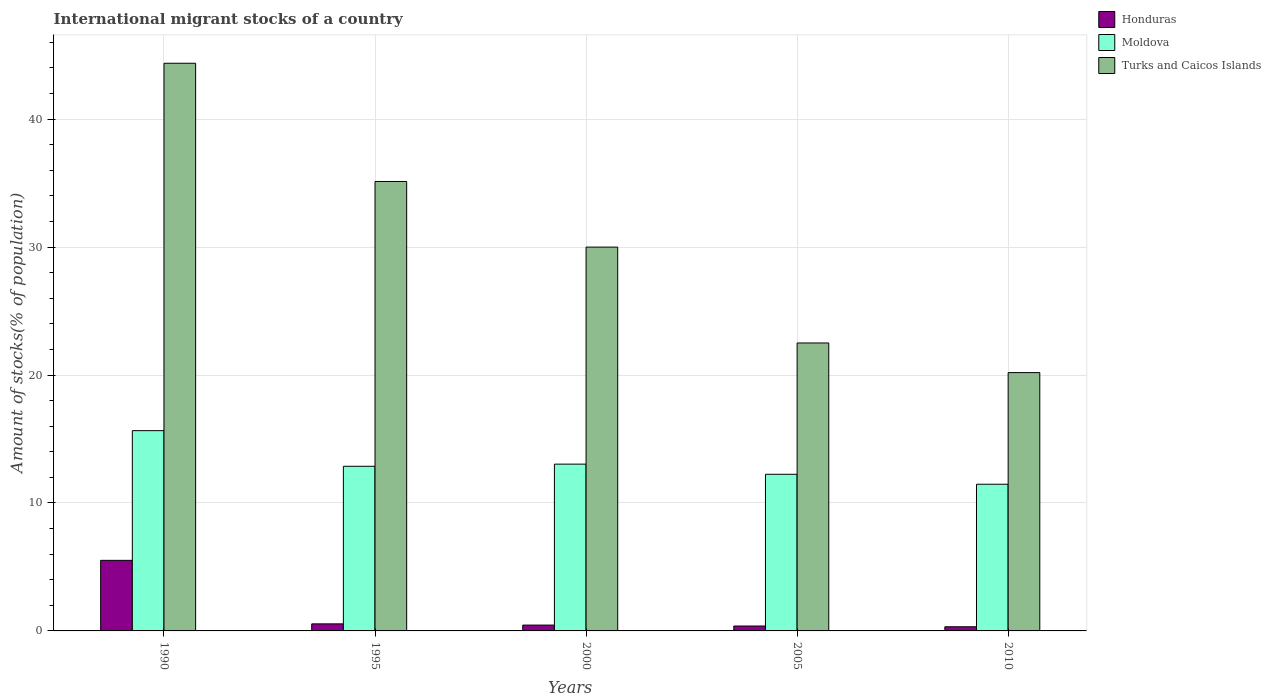How many groups of bars are there?
Your answer should be very brief. 5. Are the number of bars per tick equal to the number of legend labels?
Your answer should be very brief. Yes. Are the number of bars on each tick of the X-axis equal?
Your answer should be very brief. Yes. How many bars are there on the 3rd tick from the right?
Provide a succinct answer. 3. What is the label of the 2nd group of bars from the left?
Your answer should be very brief. 1995. In how many cases, is the number of bars for a given year not equal to the number of legend labels?
Offer a terse response. 0. What is the amount of stocks in in Honduras in 1990?
Give a very brief answer. 5.52. Across all years, what is the maximum amount of stocks in in Turks and Caicos Islands?
Provide a succinct answer. 44.36. Across all years, what is the minimum amount of stocks in in Turks and Caicos Islands?
Provide a succinct answer. 20.19. In which year was the amount of stocks in in Turks and Caicos Islands minimum?
Offer a terse response. 2010. What is the total amount of stocks in in Turks and Caicos Islands in the graph?
Make the answer very short. 152.18. What is the difference between the amount of stocks in in Turks and Caicos Islands in 1995 and that in 2005?
Provide a short and direct response. 12.62. What is the difference between the amount of stocks in in Moldova in 2005 and the amount of stocks in in Honduras in 1995?
Provide a short and direct response. 11.69. What is the average amount of stocks in in Honduras per year?
Make the answer very short. 1.45. In the year 2005, what is the difference between the amount of stocks in in Moldova and amount of stocks in in Turks and Caicos Islands?
Provide a short and direct response. -10.26. In how many years, is the amount of stocks in in Turks and Caicos Islands greater than 12 %?
Offer a very short reply. 5. What is the ratio of the amount of stocks in in Turks and Caicos Islands in 2000 to that in 2005?
Keep it short and to the point. 1.33. Is the amount of stocks in in Turks and Caicos Islands in 1990 less than that in 1995?
Offer a terse response. No. What is the difference between the highest and the second highest amount of stocks in in Honduras?
Keep it short and to the point. 4.96. What is the difference between the highest and the lowest amount of stocks in in Turks and Caicos Islands?
Make the answer very short. 24.18. In how many years, is the amount of stocks in in Honduras greater than the average amount of stocks in in Honduras taken over all years?
Offer a terse response. 1. Is the sum of the amount of stocks in in Moldova in 1990 and 2005 greater than the maximum amount of stocks in in Honduras across all years?
Your answer should be very brief. Yes. What does the 1st bar from the left in 2010 represents?
Ensure brevity in your answer.  Honduras. What does the 3rd bar from the right in 2010 represents?
Keep it short and to the point. Honduras. Is it the case that in every year, the sum of the amount of stocks in in Honduras and amount of stocks in in Moldova is greater than the amount of stocks in in Turks and Caicos Islands?
Offer a very short reply. No. What is the difference between two consecutive major ticks on the Y-axis?
Provide a succinct answer. 10. Does the graph contain any zero values?
Provide a short and direct response. No. How many legend labels are there?
Give a very brief answer. 3. What is the title of the graph?
Offer a terse response. International migrant stocks of a country. What is the label or title of the Y-axis?
Ensure brevity in your answer.  Amount of stocks(% of population). What is the Amount of stocks(% of population) in Honduras in 1990?
Offer a terse response. 5.52. What is the Amount of stocks(% of population) of Moldova in 1990?
Ensure brevity in your answer.  15.65. What is the Amount of stocks(% of population) of Turks and Caicos Islands in 1990?
Make the answer very short. 44.36. What is the Amount of stocks(% of population) of Honduras in 1995?
Provide a succinct answer. 0.55. What is the Amount of stocks(% of population) of Moldova in 1995?
Your answer should be very brief. 12.87. What is the Amount of stocks(% of population) of Turks and Caicos Islands in 1995?
Ensure brevity in your answer.  35.12. What is the Amount of stocks(% of population) in Honduras in 2000?
Make the answer very short. 0.46. What is the Amount of stocks(% of population) in Moldova in 2000?
Your response must be concise. 13.03. What is the Amount of stocks(% of population) in Turks and Caicos Islands in 2000?
Your answer should be very brief. 30. What is the Amount of stocks(% of population) in Honduras in 2005?
Your answer should be compact. 0.38. What is the Amount of stocks(% of population) in Moldova in 2005?
Ensure brevity in your answer.  12.24. What is the Amount of stocks(% of population) in Turks and Caicos Islands in 2005?
Ensure brevity in your answer.  22.5. What is the Amount of stocks(% of population) in Honduras in 2010?
Keep it short and to the point. 0.32. What is the Amount of stocks(% of population) in Moldova in 2010?
Make the answer very short. 11.46. What is the Amount of stocks(% of population) in Turks and Caicos Islands in 2010?
Give a very brief answer. 20.19. Across all years, what is the maximum Amount of stocks(% of population) in Honduras?
Offer a very short reply. 5.52. Across all years, what is the maximum Amount of stocks(% of population) in Moldova?
Offer a terse response. 15.65. Across all years, what is the maximum Amount of stocks(% of population) of Turks and Caicos Islands?
Your response must be concise. 44.36. Across all years, what is the minimum Amount of stocks(% of population) in Honduras?
Make the answer very short. 0.32. Across all years, what is the minimum Amount of stocks(% of population) of Moldova?
Your answer should be compact. 11.46. Across all years, what is the minimum Amount of stocks(% of population) of Turks and Caicos Islands?
Give a very brief answer. 20.19. What is the total Amount of stocks(% of population) in Honduras in the graph?
Provide a short and direct response. 7.23. What is the total Amount of stocks(% of population) in Moldova in the graph?
Ensure brevity in your answer.  65.26. What is the total Amount of stocks(% of population) of Turks and Caicos Islands in the graph?
Give a very brief answer. 152.18. What is the difference between the Amount of stocks(% of population) in Honduras in 1990 and that in 1995?
Your response must be concise. 4.96. What is the difference between the Amount of stocks(% of population) in Moldova in 1990 and that in 1995?
Ensure brevity in your answer.  2.78. What is the difference between the Amount of stocks(% of population) of Turks and Caicos Islands in 1990 and that in 1995?
Keep it short and to the point. 9.24. What is the difference between the Amount of stocks(% of population) in Honduras in 1990 and that in 2000?
Make the answer very short. 5.06. What is the difference between the Amount of stocks(% of population) of Moldova in 1990 and that in 2000?
Your answer should be very brief. 2.62. What is the difference between the Amount of stocks(% of population) of Turks and Caicos Islands in 1990 and that in 2000?
Your response must be concise. 14.37. What is the difference between the Amount of stocks(% of population) of Honduras in 1990 and that in 2005?
Give a very brief answer. 5.13. What is the difference between the Amount of stocks(% of population) of Moldova in 1990 and that in 2005?
Your response must be concise. 3.41. What is the difference between the Amount of stocks(% of population) of Turks and Caicos Islands in 1990 and that in 2005?
Make the answer very short. 21.86. What is the difference between the Amount of stocks(% of population) in Honduras in 1990 and that in 2010?
Provide a short and direct response. 5.19. What is the difference between the Amount of stocks(% of population) in Moldova in 1990 and that in 2010?
Ensure brevity in your answer.  4.19. What is the difference between the Amount of stocks(% of population) of Turks and Caicos Islands in 1990 and that in 2010?
Make the answer very short. 24.18. What is the difference between the Amount of stocks(% of population) in Honduras in 1995 and that in 2000?
Give a very brief answer. 0.1. What is the difference between the Amount of stocks(% of population) of Turks and Caicos Islands in 1995 and that in 2000?
Your response must be concise. 5.13. What is the difference between the Amount of stocks(% of population) of Honduras in 1995 and that in 2005?
Offer a terse response. 0.17. What is the difference between the Amount of stocks(% of population) of Moldova in 1995 and that in 2005?
Make the answer very short. 0.63. What is the difference between the Amount of stocks(% of population) of Turks and Caicos Islands in 1995 and that in 2005?
Give a very brief answer. 12.62. What is the difference between the Amount of stocks(% of population) of Honduras in 1995 and that in 2010?
Give a very brief answer. 0.23. What is the difference between the Amount of stocks(% of population) in Moldova in 1995 and that in 2010?
Make the answer very short. 1.4. What is the difference between the Amount of stocks(% of population) in Turks and Caicos Islands in 1995 and that in 2010?
Make the answer very short. 14.94. What is the difference between the Amount of stocks(% of population) in Honduras in 2000 and that in 2005?
Keep it short and to the point. 0.07. What is the difference between the Amount of stocks(% of population) of Moldova in 2000 and that in 2005?
Offer a terse response. 0.79. What is the difference between the Amount of stocks(% of population) of Turks and Caicos Islands in 2000 and that in 2005?
Your answer should be very brief. 7.49. What is the difference between the Amount of stocks(% of population) in Honduras in 2000 and that in 2010?
Make the answer very short. 0.13. What is the difference between the Amount of stocks(% of population) of Moldova in 2000 and that in 2010?
Provide a succinct answer. 1.57. What is the difference between the Amount of stocks(% of population) in Turks and Caicos Islands in 2000 and that in 2010?
Offer a very short reply. 9.81. What is the difference between the Amount of stocks(% of population) in Honduras in 2005 and that in 2010?
Make the answer very short. 0.06. What is the difference between the Amount of stocks(% of population) of Moldova in 2005 and that in 2010?
Your answer should be very brief. 0.78. What is the difference between the Amount of stocks(% of population) in Turks and Caicos Islands in 2005 and that in 2010?
Give a very brief answer. 2.31. What is the difference between the Amount of stocks(% of population) of Honduras in 1990 and the Amount of stocks(% of population) of Moldova in 1995?
Your answer should be compact. -7.35. What is the difference between the Amount of stocks(% of population) of Honduras in 1990 and the Amount of stocks(% of population) of Turks and Caicos Islands in 1995?
Offer a very short reply. -29.61. What is the difference between the Amount of stocks(% of population) of Moldova in 1990 and the Amount of stocks(% of population) of Turks and Caicos Islands in 1995?
Offer a terse response. -19.47. What is the difference between the Amount of stocks(% of population) in Honduras in 1990 and the Amount of stocks(% of population) in Moldova in 2000?
Give a very brief answer. -7.52. What is the difference between the Amount of stocks(% of population) of Honduras in 1990 and the Amount of stocks(% of population) of Turks and Caicos Islands in 2000?
Offer a very short reply. -24.48. What is the difference between the Amount of stocks(% of population) of Moldova in 1990 and the Amount of stocks(% of population) of Turks and Caicos Islands in 2000?
Offer a terse response. -14.34. What is the difference between the Amount of stocks(% of population) in Honduras in 1990 and the Amount of stocks(% of population) in Moldova in 2005?
Provide a short and direct response. -6.73. What is the difference between the Amount of stocks(% of population) of Honduras in 1990 and the Amount of stocks(% of population) of Turks and Caicos Islands in 2005?
Offer a terse response. -16.99. What is the difference between the Amount of stocks(% of population) in Moldova in 1990 and the Amount of stocks(% of population) in Turks and Caicos Islands in 2005?
Make the answer very short. -6.85. What is the difference between the Amount of stocks(% of population) of Honduras in 1990 and the Amount of stocks(% of population) of Moldova in 2010?
Give a very brief answer. -5.95. What is the difference between the Amount of stocks(% of population) in Honduras in 1990 and the Amount of stocks(% of population) in Turks and Caicos Islands in 2010?
Offer a terse response. -14.67. What is the difference between the Amount of stocks(% of population) in Moldova in 1990 and the Amount of stocks(% of population) in Turks and Caicos Islands in 2010?
Offer a terse response. -4.54. What is the difference between the Amount of stocks(% of population) of Honduras in 1995 and the Amount of stocks(% of population) of Moldova in 2000?
Give a very brief answer. -12.48. What is the difference between the Amount of stocks(% of population) in Honduras in 1995 and the Amount of stocks(% of population) in Turks and Caicos Islands in 2000?
Your answer should be very brief. -29.44. What is the difference between the Amount of stocks(% of population) in Moldova in 1995 and the Amount of stocks(% of population) in Turks and Caicos Islands in 2000?
Keep it short and to the point. -17.13. What is the difference between the Amount of stocks(% of population) in Honduras in 1995 and the Amount of stocks(% of population) in Moldova in 2005?
Provide a succinct answer. -11.69. What is the difference between the Amount of stocks(% of population) in Honduras in 1995 and the Amount of stocks(% of population) in Turks and Caicos Islands in 2005?
Your answer should be very brief. -21.95. What is the difference between the Amount of stocks(% of population) of Moldova in 1995 and the Amount of stocks(% of population) of Turks and Caicos Islands in 2005?
Ensure brevity in your answer.  -9.64. What is the difference between the Amount of stocks(% of population) of Honduras in 1995 and the Amount of stocks(% of population) of Moldova in 2010?
Give a very brief answer. -10.91. What is the difference between the Amount of stocks(% of population) of Honduras in 1995 and the Amount of stocks(% of population) of Turks and Caicos Islands in 2010?
Your response must be concise. -19.64. What is the difference between the Amount of stocks(% of population) in Moldova in 1995 and the Amount of stocks(% of population) in Turks and Caicos Islands in 2010?
Your answer should be very brief. -7.32. What is the difference between the Amount of stocks(% of population) of Honduras in 2000 and the Amount of stocks(% of population) of Moldova in 2005?
Give a very brief answer. -11.79. What is the difference between the Amount of stocks(% of population) in Honduras in 2000 and the Amount of stocks(% of population) in Turks and Caicos Islands in 2005?
Give a very brief answer. -22.05. What is the difference between the Amount of stocks(% of population) in Moldova in 2000 and the Amount of stocks(% of population) in Turks and Caicos Islands in 2005?
Provide a short and direct response. -9.47. What is the difference between the Amount of stocks(% of population) in Honduras in 2000 and the Amount of stocks(% of population) in Moldova in 2010?
Give a very brief answer. -11.01. What is the difference between the Amount of stocks(% of population) in Honduras in 2000 and the Amount of stocks(% of population) in Turks and Caicos Islands in 2010?
Offer a terse response. -19.73. What is the difference between the Amount of stocks(% of population) in Moldova in 2000 and the Amount of stocks(% of population) in Turks and Caicos Islands in 2010?
Provide a succinct answer. -7.15. What is the difference between the Amount of stocks(% of population) of Honduras in 2005 and the Amount of stocks(% of population) of Moldova in 2010?
Provide a short and direct response. -11.08. What is the difference between the Amount of stocks(% of population) in Honduras in 2005 and the Amount of stocks(% of population) in Turks and Caicos Islands in 2010?
Keep it short and to the point. -19.81. What is the difference between the Amount of stocks(% of population) in Moldova in 2005 and the Amount of stocks(% of population) in Turks and Caicos Islands in 2010?
Provide a succinct answer. -7.95. What is the average Amount of stocks(% of population) in Honduras per year?
Offer a terse response. 1.45. What is the average Amount of stocks(% of population) of Moldova per year?
Your answer should be compact. 13.05. What is the average Amount of stocks(% of population) of Turks and Caicos Islands per year?
Provide a short and direct response. 30.43. In the year 1990, what is the difference between the Amount of stocks(% of population) of Honduras and Amount of stocks(% of population) of Moldova?
Offer a terse response. -10.14. In the year 1990, what is the difference between the Amount of stocks(% of population) in Honduras and Amount of stocks(% of population) in Turks and Caicos Islands?
Make the answer very short. -38.85. In the year 1990, what is the difference between the Amount of stocks(% of population) in Moldova and Amount of stocks(% of population) in Turks and Caicos Islands?
Offer a very short reply. -28.71. In the year 1995, what is the difference between the Amount of stocks(% of population) in Honduras and Amount of stocks(% of population) in Moldova?
Make the answer very short. -12.32. In the year 1995, what is the difference between the Amount of stocks(% of population) in Honduras and Amount of stocks(% of population) in Turks and Caicos Islands?
Your answer should be compact. -34.57. In the year 1995, what is the difference between the Amount of stocks(% of population) in Moldova and Amount of stocks(% of population) in Turks and Caicos Islands?
Your answer should be compact. -22.26. In the year 2000, what is the difference between the Amount of stocks(% of population) of Honduras and Amount of stocks(% of population) of Moldova?
Ensure brevity in your answer.  -12.58. In the year 2000, what is the difference between the Amount of stocks(% of population) in Honduras and Amount of stocks(% of population) in Turks and Caicos Islands?
Give a very brief answer. -29.54. In the year 2000, what is the difference between the Amount of stocks(% of population) of Moldova and Amount of stocks(% of population) of Turks and Caicos Islands?
Offer a very short reply. -16.96. In the year 2005, what is the difference between the Amount of stocks(% of population) of Honduras and Amount of stocks(% of population) of Moldova?
Offer a very short reply. -11.86. In the year 2005, what is the difference between the Amount of stocks(% of population) in Honduras and Amount of stocks(% of population) in Turks and Caicos Islands?
Keep it short and to the point. -22.12. In the year 2005, what is the difference between the Amount of stocks(% of population) of Moldova and Amount of stocks(% of population) of Turks and Caicos Islands?
Ensure brevity in your answer.  -10.26. In the year 2010, what is the difference between the Amount of stocks(% of population) of Honduras and Amount of stocks(% of population) of Moldova?
Offer a terse response. -11.14. In the year 2010, what is the difference between the Amount of stocks(% of population) of Honduras and Amount of stocks(% of population) of Turks and Caicos Islands?
Make the answer very short. -19.86. In the year 2010, what is the difference between the Amount of stocks(% of population) in Moldova and Amount of stocks(% of population) in Turks and Caicos Islands?
Provide a short and direct response. -8.73. What is the ratio of the Amount of stocks(% of population) in Honduras in 1990 to that in 1995?
Keep it short and to the point. 9.99. What is the ratio of the Amount of stocks(% of population) in Moldova in 1990 to that in 1995?
Keep it short and to the point. 1.22. What is the ratio of the Amount of stocks(% of population) of Turks and Caicos Islands in 1990 to that in 1995?
Ensure brevity in your answer.  1.26. What is the ratio of the Amount of stocks(% of population) in Honduras in 1990 to that in 2000?
Provide a succinct answer. 12.1. What is the ratio of the Amount of stocks(% of population) of Moldova in 1990 to that in 2000?
Make the answer very short. 1.2. What is the ratio of the Amount of stocks(% of population) of Turks and Caicos Islands in 1990 to that in 2000?
Offer a very short reply. 1.48. What is the ratio of the Amount of stocks(% of population) of Honduras in 1990 to that in 2005?
Make the answer very short. 14.41. What is the ratio of the Amount of stocks(% of population) of Moldova in 1990 to that in 2005?
Provide a succinct answer. 1.28. What is the ratio of the Amount of stocks(% of population) of Turks and Caicos Islands in 1990 to that in 2005?
Your answer should be very brief. 1.97. What is the ratio of the Amount of stocks(% of population) in Honduras in 1990 to that in 2010?
Offer a terse response. 17. What is the ratio of the Amount of stocks(% of population) in Moldova in 1990 to that in 2010?
Offer a very short reply. 1.37. What is the ratio of the Amount of stocks(% of population) of Turks and Caicos Islands in 1990 to that in 2010?
Offer a very short reply. 2.2. What is the ratio of the Amount of stocks(% of population) in Honduras in 1995 to that in 2000?
Your response must be concise. 1.21. What is the ratio of the Amount of stocks(% of population) of Moldova in 1995 to that in 2000?
Give a very brief answer. 0.99. What is the ratio of the Amount of stocks(% of population) of Turks and Caicos Islands in 1995 to that in 2000?
Provide a short and direct response. 1.17. What is the ratio of the Amount of stocks(% of population) of Honduras in 1995 to that in 2005?
Make the answer very short. 1.44. What is the ratio of the Amount of stocks(% of population) of Moldova in 1995 to that in 2005?
Offer a very short reply. 1.05. What is the ratio of the Amount of stocks(% of population) of Turks and Caicos Islands in 1995 to that in 2005?
Make the answer very short. 1.56. What is the ratio of the Amount of stocks(% of population) in Honduras in 1995 to that in 2010?
Your answer should be very brief. 1.7. What is the ratio of the Amount of stocks(% of population) of Moldova in 1995 to that in 2010?
Offer a very short reply. 1.12. What is the ratio of the Amount of stocks(% of population) in Turks and Caicos Islands in 1995 to that in 2010?
Provide a succinct answer. 1.74. What is the ratio of the Amount of stocks(% of population) of Honduras in 2000 to that in 2005?
Offer a terse response. 1.19. What is the ratio of the Amount of stocks(% of population) of Moldova in 2000 to that in 2005?
Ensure brevity in your answer.  1.06. What is the ratio of the Amount of stocks(% of population) of Turks and Caicos Islands in 2000 to that in 2005?
Provide a short and direct response. 1.33. What is the ratio of the Amount of stocks(% of population) of Honduras in 2000 to that in 2010?
Provide a short and direct response. 1.41. What is the ratio of the Amount of stocks(% of population) of Moldova in 2000 to that in 2010?
Your answer should be compact. 1.14. What is the ratio of the Amount of stocks(% of population) of Turks and Caicos Islands in 2000 to that in 2010?
Make the answer very short. 1.49. What is the ratio of the Amount of stocks(% of population) in Honduras in 2005 to that in 2010?
Offer a very short reply. 1.18. What is the ratio of the Amount of stocks(% of population) of Moldova in 2005 to that in 2010?
Offer a very short reply. 1.07. What is the ratio of the Amount of stocks(% of population) in Turks and Caicos Islands in 2005 to that in 2010?
Offer a terse response. 1.11. What is the difference between the highest and the second highest Amount of stocks(% of population) in Honduras?
Provide a short and direct response. 4.96. What is the difference between the highest and the second highest Amount of stocks(% of population) of Moldova?
Make the answer very short. 2.62. What is the difference between the highest and the second highest Amount of stocks(% of population) of Turks and Caicos Islands?
Ensure brevity in your answer.  9.24. What is the difference between the highest and the lowest Amount of stocks(% of population) in Honduras?
Make the answer very short. 5.19. What is the difference between the highest and the lowest Amount of stocks(% of population) in Moldova?
Keep it short and to the point. 4.19. What is the difference between the highest and the lowest Amount of stocks(% of population) in Turks and Caicos Islands?
Provide a short and direct response. 24.18. 